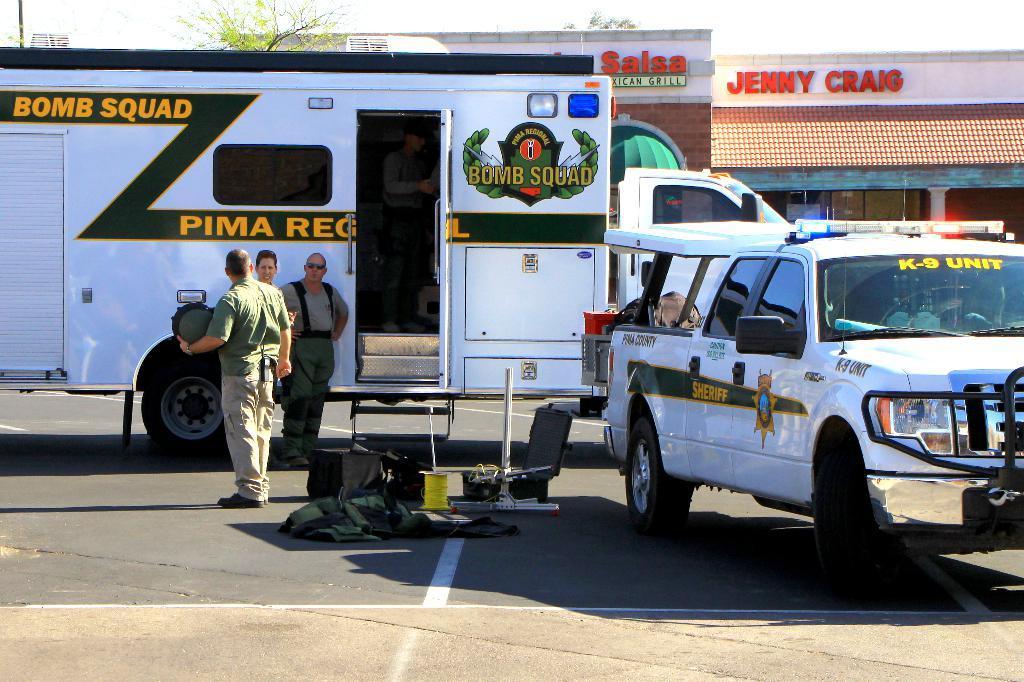Please provide a concise description of this image. In the center of the image there is a truck. There is a person standing on the road. There is a car to the right side of the image. In the background of the image there is a house. 